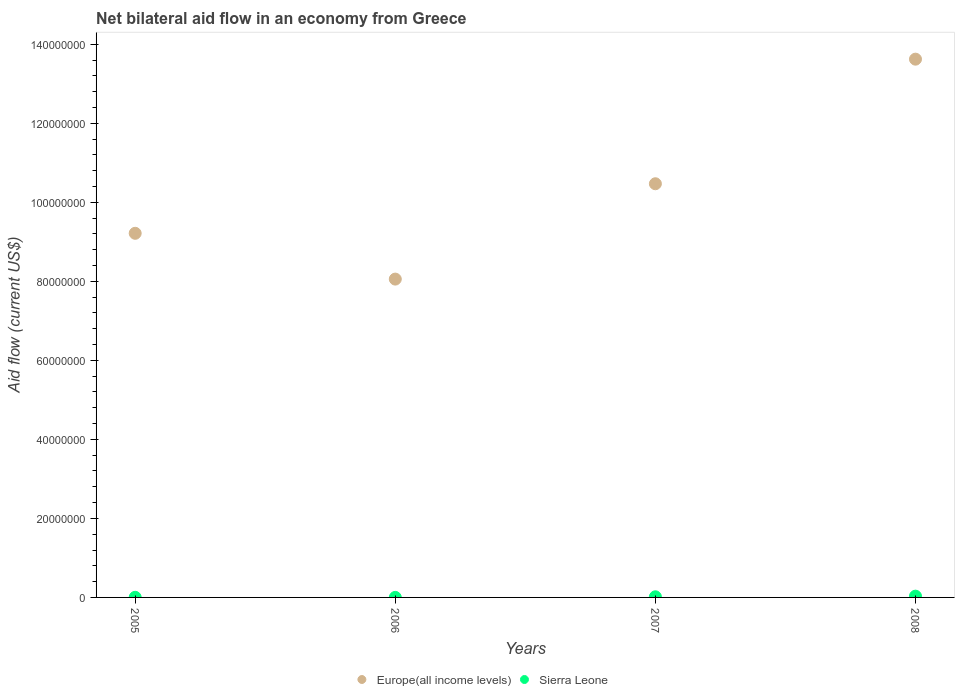What is the net bilateral aid flow in Europe(all income levels) in 2007?
Offer a terse response. 1.05e+08. Across all years, what is the maximum net bilateral aid flow in Europe(all income levels)?
Make the answer very short. 1.36e+08. Across all years, what is the minimum net bilateral aid flow in Europe(all income levels)?
Your answer should be compact. 8.06e+07. In which year was the net bilateral aid flow in Europe(all income levels) minimum?
Offer a very short reply. 2006. What is the total net bilateral aid flow in Sierra Leone in the graph?
Keep it short and to the point. 5.20e+05. What is the difference between the net bilateral aid flow in Europe(all income levels) in 2006 and that in 2007?
Provide a succinct answer. -2.41e+07. What is the difference between the net bilateral aid flow in Europe(all income levels) in 2006 and the net bilateral aid flow in Sierra Leone in 2005?
Make the answer very short. 8.05e+07. What is the average net bilateral aid flow in Europe(all income levels) per year?
Your answer should be very brief. 1.03e+08. In the year 2006, what is the difference between the net bilateral aid flow in Europe(all income levels) and net bilateral aid flow in Sierra Leone?
Your answer should be compact. 8.06e+07. What is the ratio of the net bilateral aid flow in Europe(all income levels) in 2005 to that in 2008?
Make the answer very short. 0.68. Is the difference between the net bilateral aid flow in Europe(all income levels) in 2005 and 2008 greater than the difference between the net bilateral aid flow in Sierra Leone in 2005 and 2008?
Give a very brief answer. No. What is the difference between the highest and the lowest net bilateral aid flow in Europe(all income levels)?
Ensure brevity in your answer.  5.57e+07. In how many years, is the net bilateral aid flow in Sierra Leone greater than the average net bilateral aid flow in Sierra Leone taken over all years?
Provide a succinct answer. 2. Is the net bilateral aid flow in Europe(all income levels) strictly less than the net bilateral aid flow in Sierra Leone over the years?
Offer a terse response. No. What is the difference between two consecutive major ticks on the Y-axis?
Your response must be concise. 2.00e+07. Does the graph contain any zero values?
Offer a terse response. No. Does the graph contain grids?
Your answer should be very brief. No. How many legend labels are there?
Your answer should be very brief. 2. How are the legend labels stacked?
Make the answer very short. Horizontal. What is the title of the graph?
Make the answer very short. Net bilateral aid flow in an economy from Greece. Does "Argentina" appear as one of the legend labels in the graph?
Ensure brevity in your answer.  No. What is the label or title of the X-axis?
Your answer should be compact. Years. What is the Aid flow (current US$) of Europe(all income levels) in 2005?
Offer a terse response. 9.22e+07. What is the Aid flow (current US$) of Europe(all income levels) in 2006?
Give a very brief answer. 8.06e+07. What is the Aid flow (current US$) in Europe(all income levels) in 2007?
Your response must be concise. 1.05e+08. What is the Aid flow (current US$) of Sierra Leone in 2007?
Your answer should be compact. 1.60e+05. What is the Aid flow (current US$) in Europe(all income levels) in 2008?
Your response must be concise. 1.36e+08. What is the Aid flow (current US$) in Sierra Leone in 2008?
Give a very brief answer. 3.20e+05. Across all years, what is the maximum Aid flow (current US$) in Europe(all income levels)?
Keep it short and to the point. 1.36e+08. Across all years, what is the maximum Aid flow (current US$) in Sierra Leone?
Provide a succinct answer. 3.20e+05. Across all years, what is the minimum Aid flow (current US$) in Europe(all income levels)?
Ensure brevity in your answer.  8.06e+07. Across all years, what is the minimum Aid flow (current US$) in Sierra Leone?
Provide a succinct answer. 10000. What is the total Aid flow (current US$) in Europe(all income levels) in the graph?
Your response must be concise. 4.14e+08. What is the total Aid flow (current US$) in Sierra Leone in the graph?
Your answer should be very brief. 5.20e+05. What is the difference between the Aid flow (current US$) in Europe(all income levels) in 2005 and that in 2006?
Offer a terse response. 1.16e+07. What is the difference between the Aid flow (current US$) in Europe(all income levels) in 2005 and that in 2007?
Offer a terse response. -1.25e+07. What is the difference between the Aid flow (current US$) in Europe(all income levels) in 2005 and that in 2008?
Ensure brevity in your answer.  -4.41e+07. What is the difference between the Aid flow (current US$) in Europe(all income levels) in 2006 and that in 2007?
Provide a short and direct response. -2.41e+07. What is the difference between the Aid flow (current US$) of Europe(all income levels) in 2006 and that in 2008?
Provide a short and direct response. -5.57e+07. What is the difference between the Aid flow (current US$) of Sierra Leone in 2006 and that in 2008?
Provide a succinct answer. -3.10e+05. What is the difference between the Aid flow (current US$) in Europe(all income levels) in 2007 and that in 2008?
Offer a terse response. -3.15e+07. What is the difference between the Aid flow (current US$) of Sierra Leone in 2007 and that in 2008?
Ensure brevity in your answer.  -1.60e+05. What is the difference between the Aid flow (current US$) of Europe(all income levels) in 2005 and the Aid flow (current US$) of Sierra Leone in 2006?
Provide a short and direct response. 9.21e+07. What is the difference between the Aid flow (current US$) of Europe(all income levels) in 2005 and the Aid flow (current US$) of Sierra Leone in 2007?
Offer a terse response. 9.20e+07. What is the difference between the Aid flow (current US$) of Europe(all income levels) in 2005 and the Aid flow (current US$) of Sierra Leone in 2008?
Provide a short and direct response. 9.18e+07. What is the difference between the Aid flow (current US$) in Europe(all income levels) in 2006 and the Aid flow (current US$) in Sierra Leone in 2007?
Provide a succinct answer. 8.04e+07. What is the difference between the Aid flow (current US$) of Europe(all income levels) in 2006 and the Aid flow (current US$) of Sierra Leone in 2008?
Provide a succinct answer. 8.02e+07. What is the difference between the Aid flow (current US$) of Europe(all income levels) in 2007 and the Aid flow (current US$) of Sierra Leone in 2008?
Provide a short and direct response. 1.04e+08. What is the average Aid flow (current US$) in Europe(all income levels) per year?
Your answer should be compact. 1.03e+08. In the year 2005, what is the difference between the Aid flow (current US$) in Europe(all income levels) and Aid flow (current US$) in Sierra Leone?
Ensure brevity in your answer.  9.21e+07. In the year 2006, what is the difference between the Aid flow (current US$) of Europe(all income levels) and Aid flow (current US$) of Sierra Leone?
Provide a succinct answer. 8.06e+07. In the year 2007, what is the difference between the Aid flow (current US$) in Europe(all income levels) and Aid flow (current US$) in Sierra Leone?
Provide a succinct answer. 1.05e+08. In the year 2008, what is the difference between the Aid flow (current US$) in Europe(all income levels) and Aid flow (current US$) in Sierra Leone?
Offer a very short reply. 1.36e+08. What is the ratio of the Aid flow (current US$) in Europe(all income levels) in 2005 to that in 2006?
Give a very brief answer. 1.14. What is the ratio of the Aid flow (current US$) in Europe(all income levels) in 2005 to that in 2007?
Ensure brevity in your answer.  0.88. What is the ratio of the Aid flow (current US$) of Sierra Leone in 2005 to that in 2007?
Offer a very short reply. 0.19. What is the ratio of the Aid flow (current US$) of Europe(all income levels) in 2005 to that in 2008?
Offer a very short reply. 0.68. What is the ratio of the Aid flow (current US$) in Sierra Leone in 2005 to that in 2008?
Provide a succinct answer. 0.09. What is the ratio of the Aid flow (current US$) in Europe(all income levels) in 2006 to that in 2007?
Give a very brief answer. 0.77. What is the ratio of the Aid flow (current US$) of Sierra Leone in 2006 to that in 2007?
Give a very brief answer. 0.06. What is the ratio of the Aid flow (current US$) of Europe(all income levels) in 2006 to that in 2008?
Provide a short and direct response. 0.59. What is the ratio of the Aid flow (current US$) in Sierra Leone in 2006 to that in 2008?
Provide a short and direct response. 0.03. What is the ratio of the Aid flow (current US$) of Europe(all income levels) in 2007 to that in 2008?
Provide a succinct answer. 0.77. What is the ratio of the Aid flow (current US$) in Sierra Leone in 2007 to that in 2008?
Offer a very short reply. 0.5. What is the difference between the highest and the second highest Aid flow (current US$) in Europe(all income levels)?
Your answer should be compact. 3.15e+07. What is the difference between the highest and the second highest Aid flow (current US$) of Sierra Leone?
Give a very brief answer. 1.60e+05. What is the difference between the highest and the lowest Aid flow (current US$) of Europe(all income levels)?
Provide a succinct answer. 5.57e+07. 